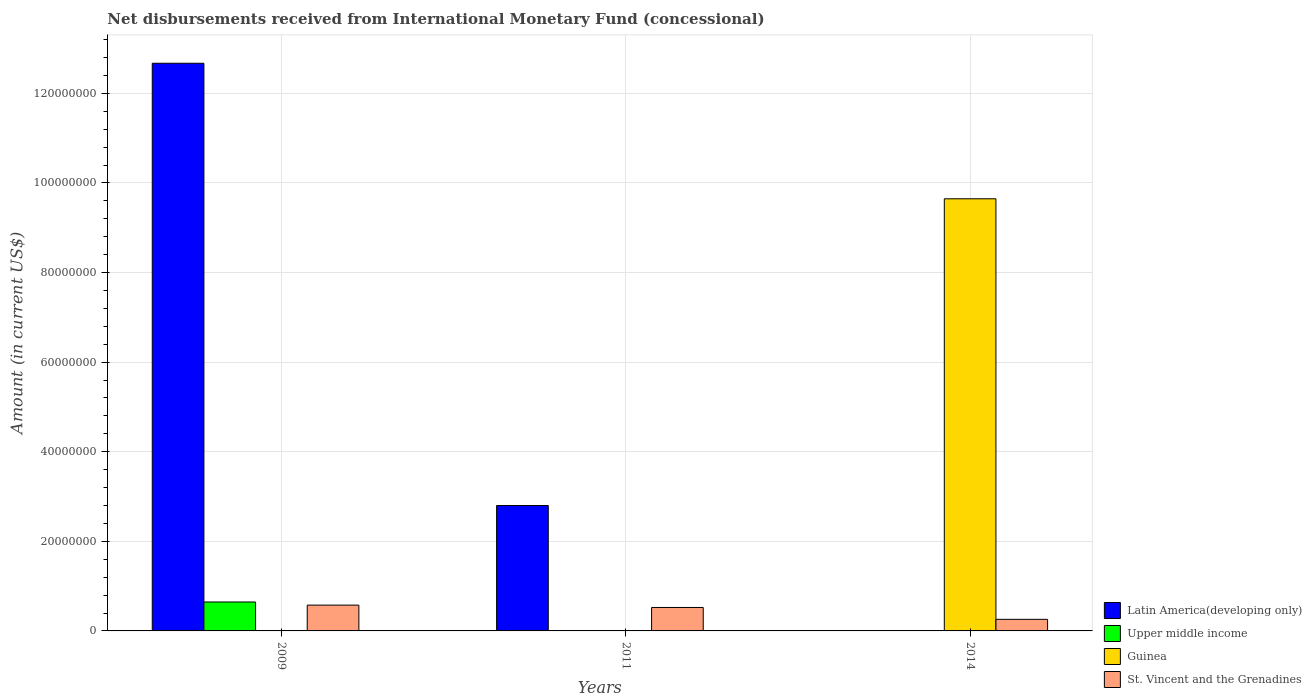How many different coloured bars are there?
Provide a succinct answer. 4. How many groups of bars are there?
Ensure brevity in your answer.  3. How many bars are there on the 1st tick from the right?
Keep it short and to the point. 2. What is the label of the 1st group of bars from the left?
Your answer should be compact. 2009. In how many cases, is the number of bars for a given year not equal to the number of legend labels?
Make the answer very short. 3. What is the amount of disbursements received from International Monetary Fund in Guinea in 2014?
Your answer should be compact. 9.65e+07. Across all years, what is the maximum amount of disbursements received from International Monetary Fund in Guinea?
Keep it short and to the point. 9.65e+07. Across all years, what is the minimum amount of disbursements received from International Monetary Fund in Latin America(developing only)?
Keep it short and to the point. 0. What is the total amount of disbursements received from International Monetary Fund in St. Vincent and the Grenadines in the graph?
Your response must be concise. 1.36e+07. What is the difference between the amount of disbursements received from International Monetary Fund in St. Vincent and the Grenadines in 2009 and that in 2014?
Offer a terse response. 3.18e+06. What is the difference between the amount of disbursements received from International Monetary Fund in Upper middle income in 2011 and the amount of disbursements received from International Monetary Fund in Guinea in 2014?
Offer a terse response. -9.65e+07. What is the average amount of disbursements received from International Monetary Fund in Latin America(developing only) per year?
Ensure brevity in your answer.  5.16e+07. In the year 2009, what is the difference between the amount of disbursements received from International Monetary Fund in Upper middle income and amount of disbursements received from International Monetary Fund in Latin America(developing only)?
Give a very brief answer. -1.20e+08. In how many years, is the amount of disbursements received from International Monetary Fund in Upper middle income greater than 60000000 US$?
Keep it short and to the point. 0. What is the ratio of the amount of disbursements received from International Monetary Fund in St. Vincent and the Grenadines in 2009 to that in 2011?
Offer a terse response. 1.1. What is the difference between the highest and the lowest amount of disbursements received from International Monetary Fund in Guinea?
Your answer should be very brief. 9.65e+07. Is the sum of the amount of disbursements received from International Monetary Fund in St. Vincent and the Grenadines in 2011 and 2014 greater than the maximum amount of disbursements received from International Monetary Fund in Latin America(developing only) across all years?
Provide a succinct answer. No. Is it the case that in every year, the sum of the amount of disbursements received from International Monetary Fund in Upper middle income and amount of disbursements received from International Monetary Fund in St. Vincent and the Grenadines is greater than the sum of amount of disbursements received from International Monetary Fund in Guinea and amount of disbursements received from International Monetary Fund in Latin America(developing only)?
Make the answer very short. No. How many bars are there?
Your answer should be very brief. 7. Are all the bars in the graph horizontal?
Make the answer very short. No. How many years are there in the graph?
Provide a short and direct response. 3. What is the difference between two consecutive major ticks on the Y-axis?
Give a very brief answer. 2.00e+07. Does the graph contain any zero values?
Your answer should be compact. Yes. Does the graph contain grids?
Offer a very short reply. Yes. Where does the legend appear in the graph?
Provide a succinct answer. Bottom right. How many legend labels are there?
Your answer should be very brief. 4. What is the title of the graph?
Your answer should be very brief. Net disbursements received from International Monetary Fund (concessional). What is the label or title of the X-axis?
Ensure brevity in your answer.  Years. What is the Amount (in current US$) in Latin America(developing only) in 2009?
Your answer should be compact. 1.27e+08. What is the Amount (in current US$) in Upper middle income in 2009?
Provide a short and direct response. 6.46e+06. What is the Amount (in current US$) in Guinea in 2009?
Offer a very short reply. 0. What is the Amount (in current US$) of St. Vincent and the Grenadines in 2009?
Provide a succinct answer. 5.76e+06. What is the Amount (in current US$) in Latin America(developing only) in 2011?
Keep it short and to the point. 2.80e+07. What is the Amount (in current US$) in St. Vincent and the Grenadines in 2011?
Make the answer very short. 5.24e+06. What is the Amount (in current US$) in Upper middle income in 2014?
Your response must be concise. 0. What is the Amount (in current US$) in Guinea in 2014?
Make the answer very short. 9.65e+07. What is the Amount (in current US$) in St. Vincent and the Grenadines in 2014?
Keep it short and to the point. 2.58e+06. Across all years, what is the maximum Amount (in current US$) in Latin America(developing only)?
Ensure brevity in your answer.  1.27e+08. Across all years, what is the maximum Amount (in current US$) of Upper middle income?
Your answer should be compact. 6.46e+06. Across all years, what is the maximum Amount (in current US$) in Guinea?
Ensure brevity in your answer.  9.65e+07. Across all years, what is the maximum Amount (in current US$) of St. Vincent and the Grenadines?
Offer a very short reply. 5.76e+06. Across all years, what is the minimum Amount (in current US$) of Upper middle income?
Provide a short and direct response. 0. Across all years, what is the minimum Amount (in current US$) of Guinea?
Provide a succinct answer. 0. Across all years, what is the minimum Amount (in current US$) in St. Vincent and the Grenadines?
Make the answer very short. 2.58e+06. What is the total Amount (in current US$) in Latin America(developing only) in the graph?
Your response must be concise. 1.55e+08. What is the total Amount (in current US$) in Upper middle income in the graph?
Give a very brief answer. 6.46e+06. What is the total Amount (in current US$) of Guinea in the graph?
Your response must be concise. 9.65e+07. What is the total Amount (in current US$) of St. Vincent and the Grenadines in the graph?
Your answer should be compact. 1.36e+07. What is the difference between the Amount (in current US$) in Latin America(developing only) in 2009 and that in 2011?
Provide a succinct answer. 9.87e+07. What is the difference between the Amount (in current US$) in St. Vincent and the Grenadines in 2009 and that in 2011?
Give a very brief answer. 5.26e+05. What is the difference between the Amount (in current US$) of St. Vincent and the Grenadines in 2009 and that in 2014?
Give a very brief answer. 3.18e+06. What is the difference between the Amount (in current US$) in St. Vincent and the Grenadines in 2011 and that in 2014?
Ensure brevity in your answer.  2.65e+06. What is the difference between the Amount (in current US$) of Latin America(developing only) in 2009 and the Amount (in current US$) of St. Vincent and the Grenadines in 2011?
Offer a very short reply. 1.21e+08. What is the difference between the Amount (in current US$) of Upper middle income in 2009 and the Amount (in current US$) of St. Vincent and the Grenadines in 2011?
Provide a short and direct response. 1.22e+06. What is the difference between the Amount (in current US$) in Latin America(developing only) in 2009 and the Amount (in current US$) in Guinea in 2014?
Ensure brevity in your answer.  3.03e+07. What is the difference between the Amount (in current US$) of Latin America(developing only) in 2009 and the Amount (in current US$) of St. Vincent and the Grenadines in 2014?
Your answer should be very brief. 1.24e+08. What is the difference between the Amount (in current US$) in Upper middle income in 2009 and the Amount (in current US$) in Guinea in 2014?
Offer a very short reply. -9.00e+07. What is the difference between the Amount (in current US$) of Upper middle income in 2009 and the Amount (in current US$) of St. Vincent and the Grenadines in 2014?
Provide a short and direct response. 3.88e+06. What is the difference between the Amount (in current US$) in Latin America(developing only) in 2011 and the Amount (in current US$) in Guinea in 2014?
Give a very brief answer. -6.85e+07. What is the difference between the Amount (in current US$) in Latin America(developing only) in 2011 and the Amount (in current US$) in St. Vincent and the Grenadines in 2014?
Your answer should be compact. 2.54e+07. What is the average Amount (in current US$) in Latin America(developing only) per year?
Your answer should be very brief. 5.16e+07. What is the average Amount (in current US$) of Upper middle income per year?
Provide a short and direct response. 2.15e+06. What is the average Amount (in current US$) in Guinea per year?
Keep it short and to the point. 3.22e+07. What is the average Amount (in current US$) in St. Vincent and the Grenadines per year?
Keep it short and to the point. 4.53e+06. In the year 2009, what is the difference between the Amount (in current US$) in Latin America(developing only) and Amount (in current US$) in Upper middle income?
Your answer should be compact. 1.20e+08. In the year 2009, what is the difference between the Amount (in current US$) of Latin America(developing only) and Amount (in current US$) of St. Vincent and the Grenadines?
Make the answer very short. 1.21e+08. In the year 2009, what is the difference between the Amount (in current US$) of Upper middle income and Amount (in current US$) of St. Vincent and the Grenadines?
Your answer should be very brief. 6.99e+05. In the year 2011, what is the difference between the Amount (in current US$) in Latin America(developing only) and Amount (in current US$) in St. Vincent and the Grenadines?
Provide a short and direct response. 2.28e+07. In the year 2014, what is the difference between the Amount (in current US$) of Guinea and Amount (in current US$) of St. Vincent and the Grenadines?
Offer a very short reply. 9.39e+07. What is the ratio of the Amount (in current US$) of Latin America(developing only) in 2009 to that in 2011?
Your response must be concise. 4.53. What is the ratio of the Amount (in current US$) in St. Vincent and the Grenadines in 2009 to that in 2011?
Make the answer very short. 1.1. What is the ratio of the Amount (in current US$) of St. Vincent and the Grenadines in 2009 to that in 2014?
Your answer should be compact. 2.23. What is the ratio of the Amount (in current US$) of St. Vincent and the Grenadines in 2011 to that in 2014?
Ensure brevity in your answer.  2.03. What is the difference between the highest and the second highest Amount (in current US$) in St. Vincent and the Grenadines?
Give a very brief answer. 5.26e+05. What is the difference between the highest and the lowest Amount (in current US$) of Latin America(developing only)?
Offer a terse response. 1.27e+08. What is the difference between the highest and the lowest Amount (in current US$) in Upper middle income?
Give a very brief answer. 6.46e+06. What is the difference between the highest and the lowest Amount (in current US$) of Guinea?
Your answer should be very brief. 9.65e+07. What is the difference between the highest and the lowest Amount (in current US$) of St. Vincent and the Grenadines?
Offer a terse response. 3.18e+06. 